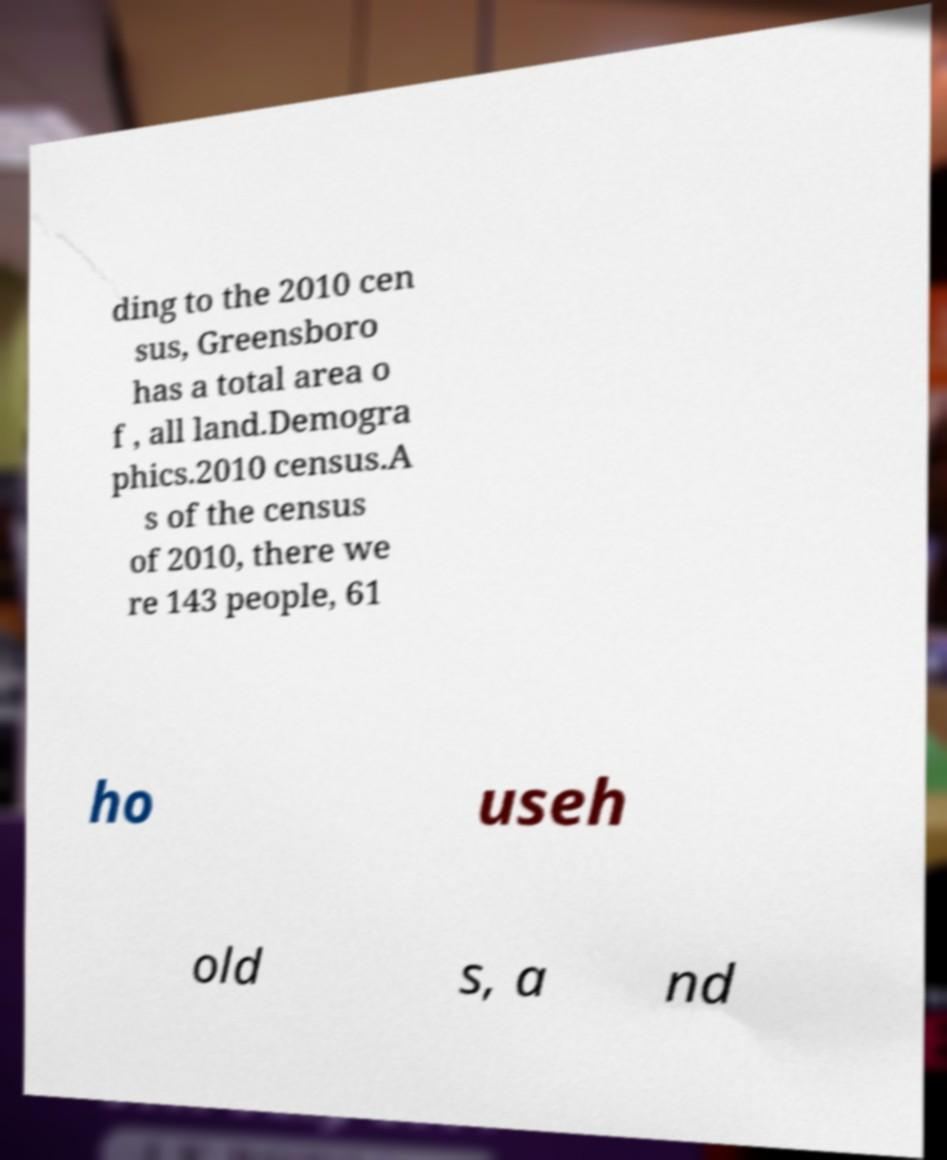Can you accurately transcribe the text from the provided image for me? ding to the 2010 cen sus, Greensboro has a total area o f , all land.Demogra phics.2010 census.A s of the census of 2010, there we re 143 people, 61 ho useh old s, a nd 